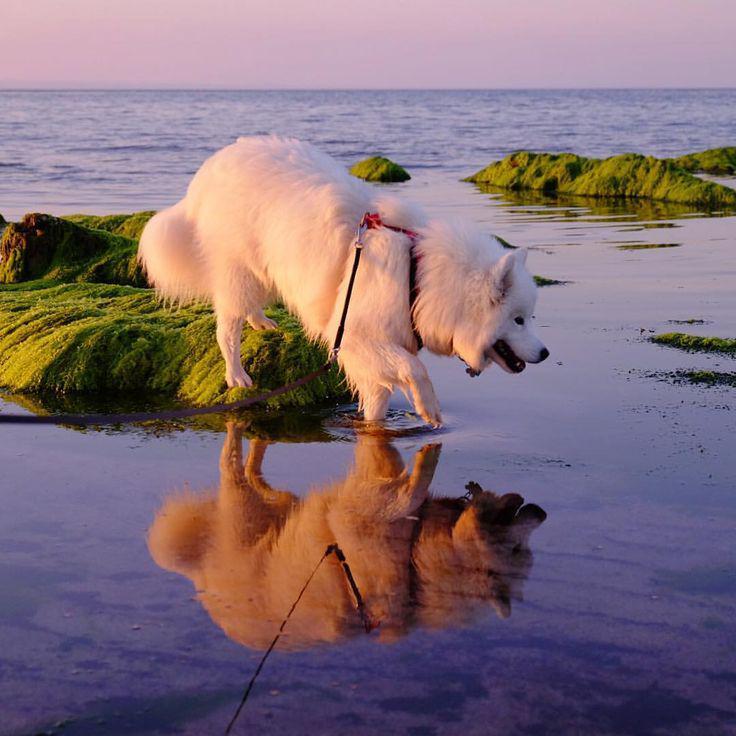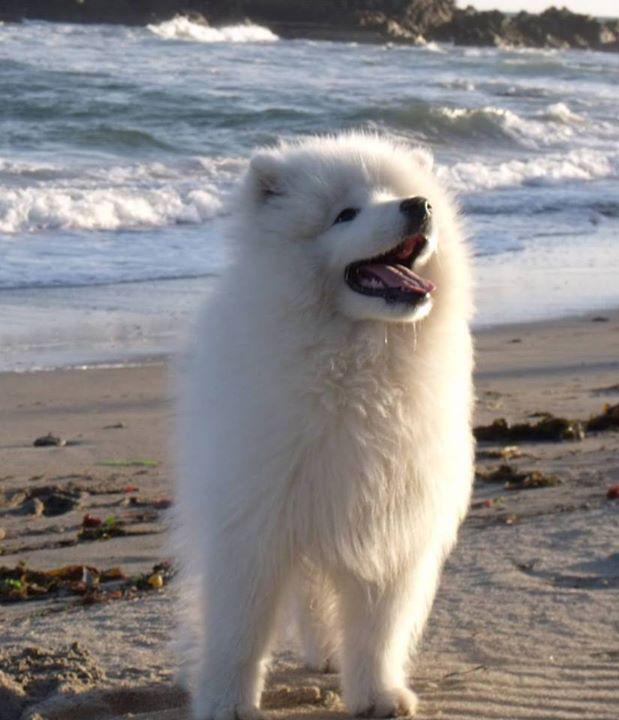The first image is the image on the left, the second image is the image on the right. Considering the images on both sides, is "A team of dogs is pulling a sled in one of the images." valid? Answer yes or no. No. The first image is the image on the left, the second image is the image on the right. For the images shown, is this caption "An image shows a rider in a sled behind a team of white sled dogs." true? Answer yes or no. No. 